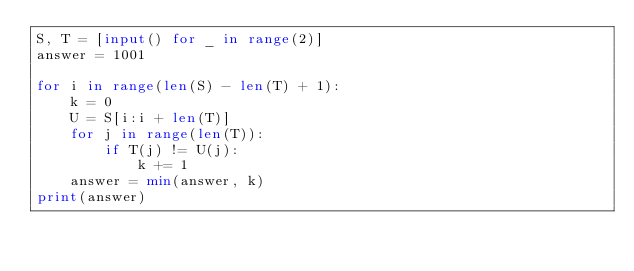<code> <loc_0><loc_0><loc_500><loc_500><_Python_>S, T = [input() for _ in range(2)]
answer = 1001

for i in range(len(S) - len(T) + 1):
	k = 0
	U = S[i:i + len(T)]
	for j in range(len(T)):
		if T(j) != U(j):
			k += 1
	answer = min(answer, k)
print(answer)</code> 